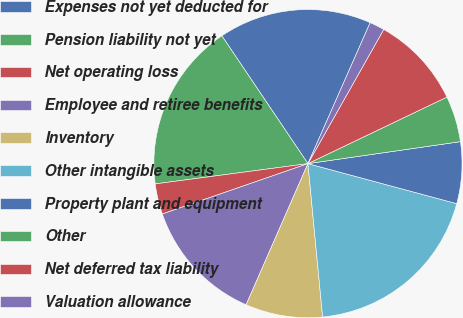<chart> <loc_0><loc_0><loc_500><loc_500><pie_chart><fcel>Expenses not yet deducted for<fcel>Pension liability not yet<fcel>Net operating loss<fcel>Employee and retiree benefits<fcel>Inventory<fcel>Other intangible assets<fcel>Property plant and equipment<fcel>Other<fcel>Net deferred tax liability<fcel>Valuation allowance<nl><fcel>16.05%<fcel>17.67%<fcel>3.2%<fcel>13.13%<fcel>8.09%<fcel>19.3%<fcel>6.46%<fcel>4.83%<fcel>9.71%<fcel>1.57%<nl></chart> 